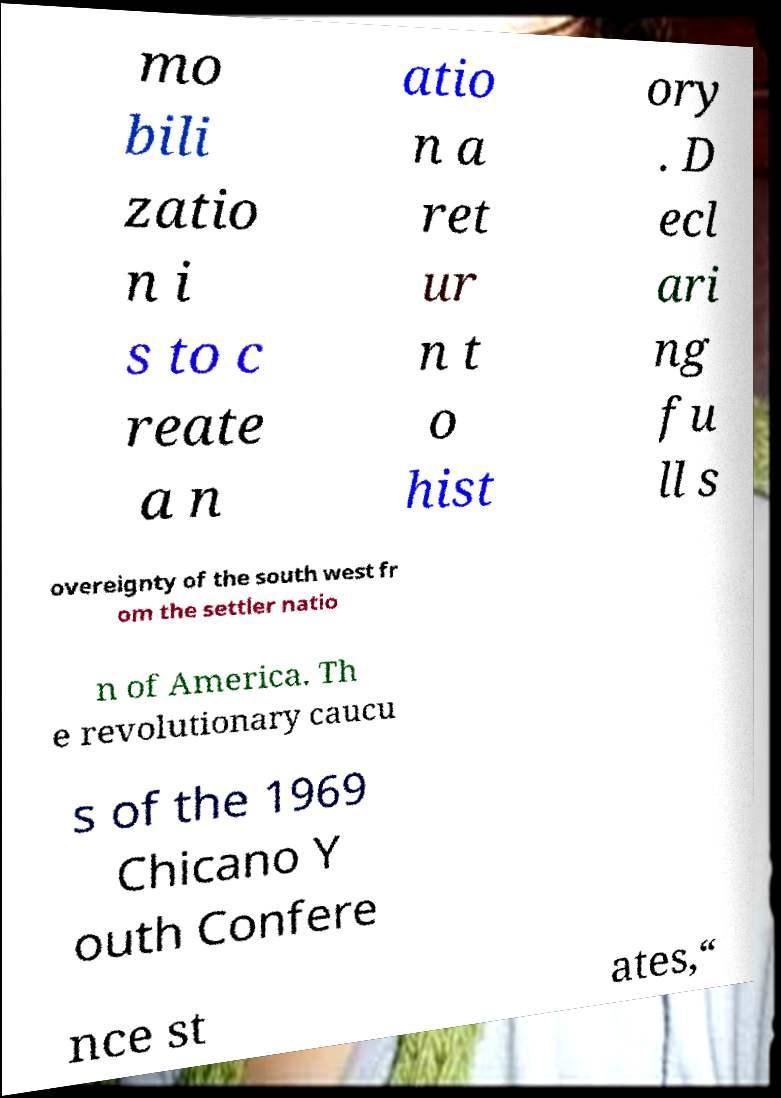Can you accurately transcribe the text from the provided image for me? mo bili zatio n i s to c reate a n atio n a ret ur n t o hist ory . D ecl ari ng fu ll s overeignty of the south west fr om the settler natio n of America. Th e revolutionary caucu s of the 1969 Chicano Y outh Confere nce st ates,“ 